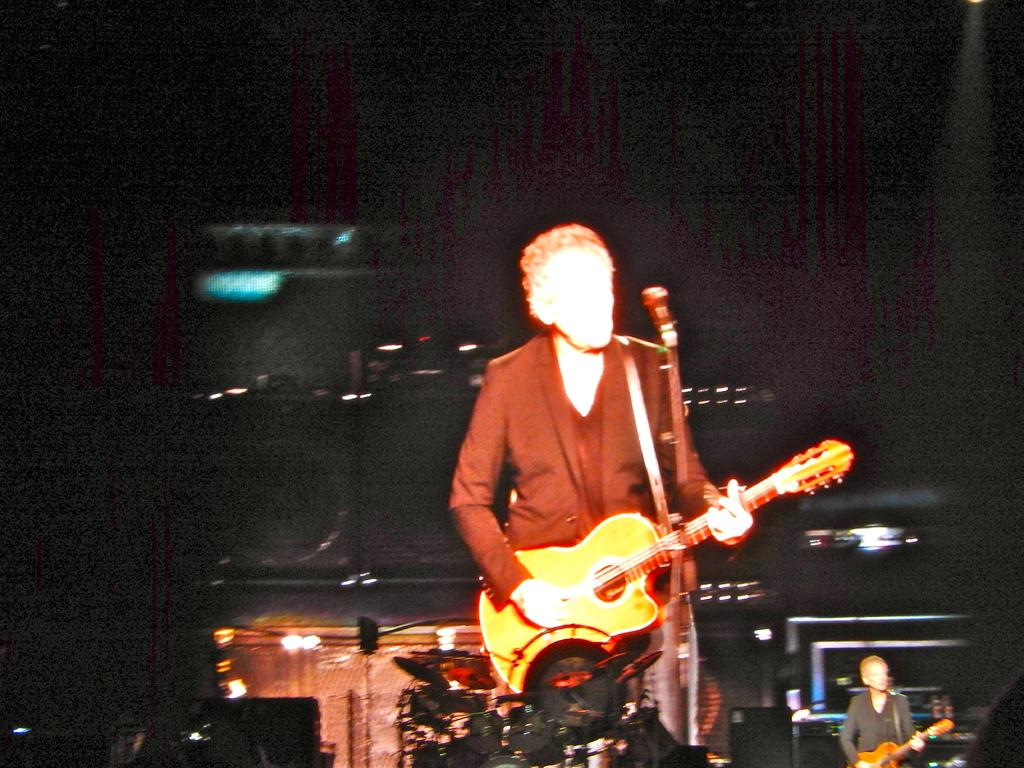What is the color of the background in the image? The background of the image is dark. How many people are in the image? There are two men in the image. What are the men doing in the image? The men are standing in front of microphones and playing guitars. What type of vegetable is being used as a prop by one of the men in the image? There is no vegetable present in the image; the men are playing guitars and standing in front of microphones. 